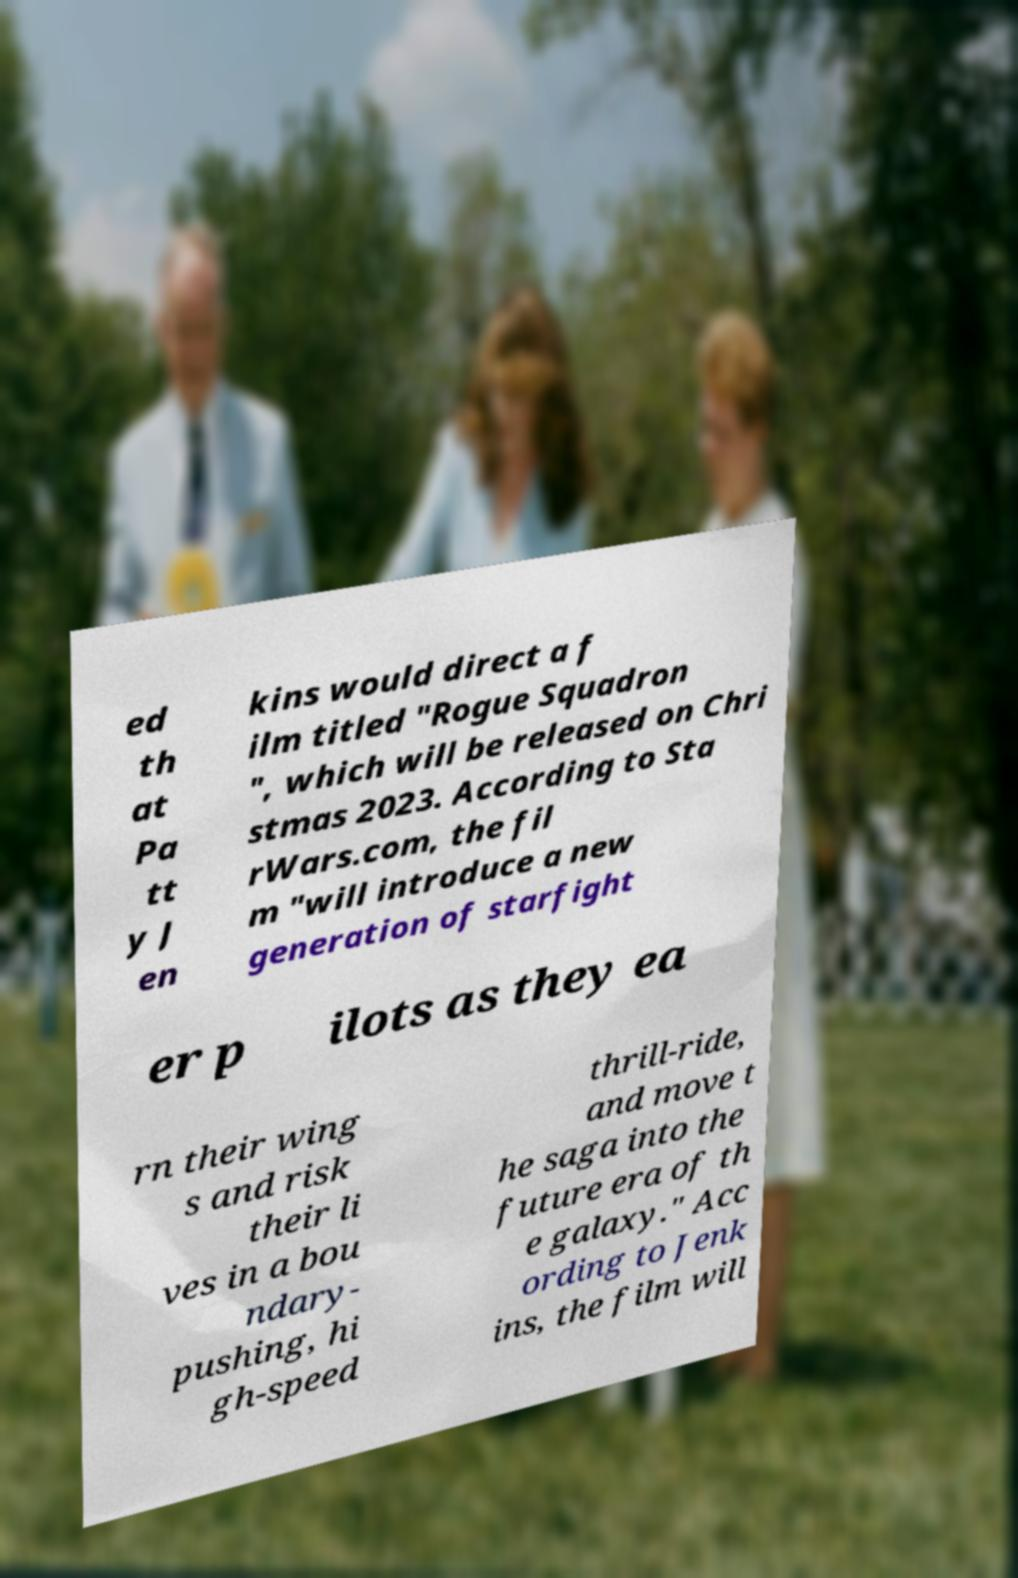What messages or text are displayed in this image? I need them in a readable, typed format. ed th at Pa tt y J en kins would direct a f ilm titled "Rogue Squadron ", which will be released on Chri stmas 2023. According to Sta rWars.com, the fil m "will introduce a new generation of starfight er p ilots as they ea rn their wing s and risk their li ves in a bou ndary- pushing, hi gh-speed thrill-ride, and move t he saga into the future era of th e galaxy." Acc ording to Jenk ins, the film will 